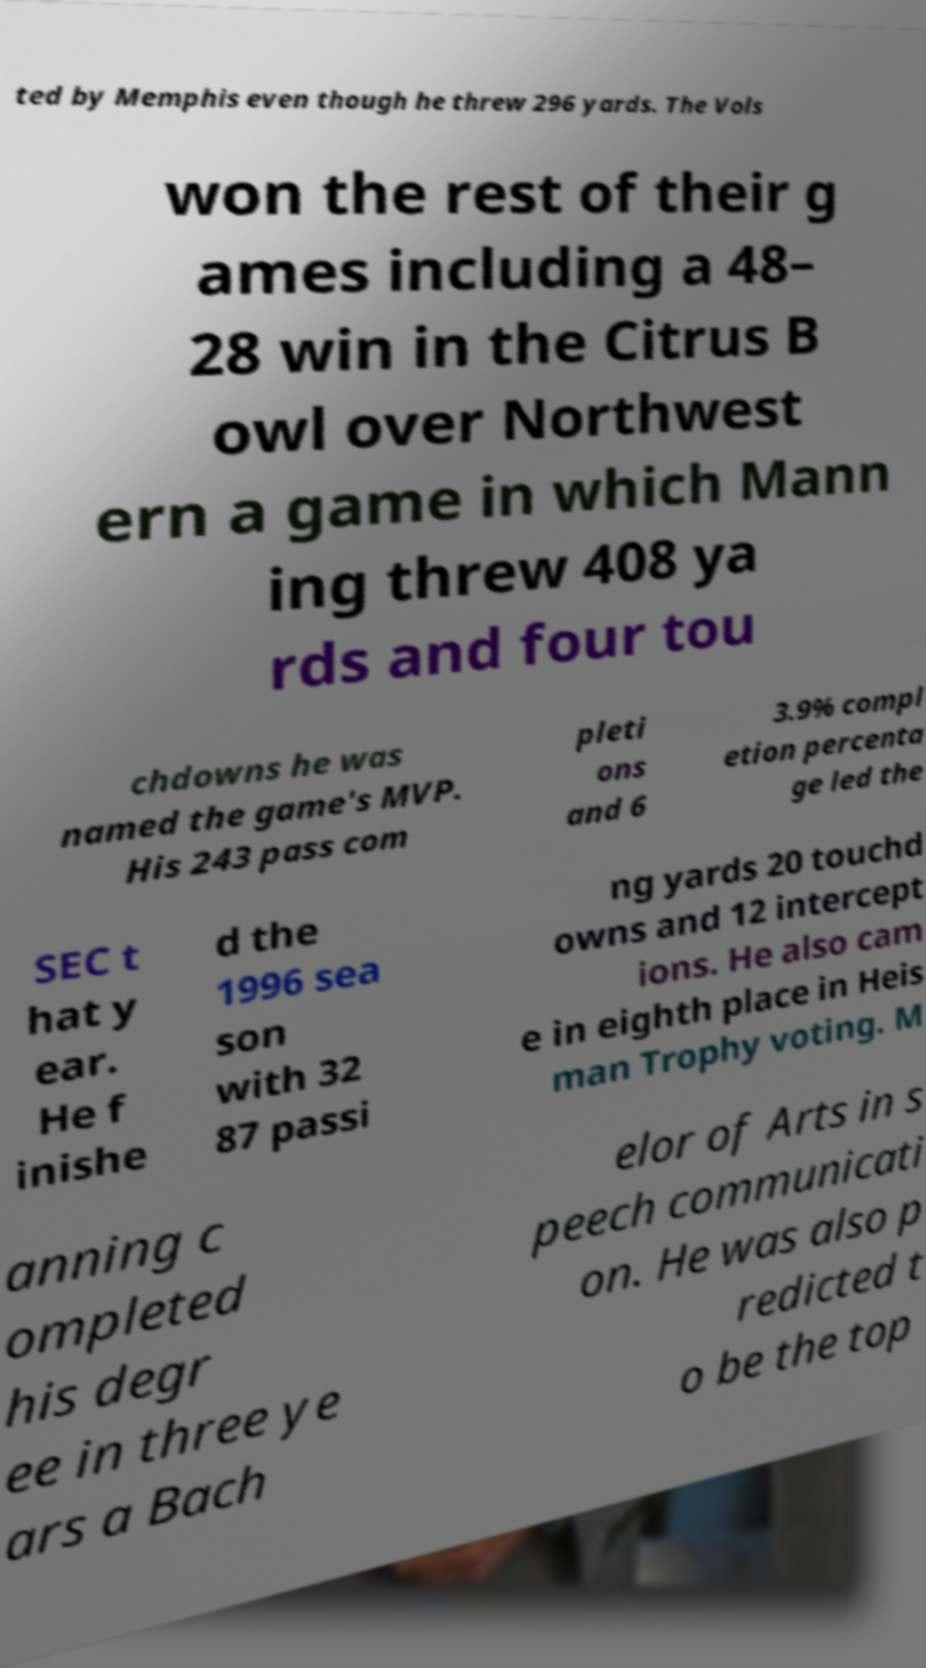For documentation purposes, I need the text within this image transcribed. Could you provide that? ted by Memphis even though he threw 296 yards. The Vols won the rest of their g ames including a 48– 28 win in the Citrus B owl over Northwest ern a game in which Mann ing threw 408 ya rds and four tou chdowns he was named the game's MVP. His 243 pass com pleti ons and 6 3.9% compl etion percenta ge led the SEC t hat y ear. He f inishe d the 1996 sea son with 32 87 passi ng yards 20 touchd owns and 12 intercept ions. He also cam e in eighth place in Heis man Trophy voting. M anning c ompleted his degr ee in three ye ars a Bach elor of Arts in s peech communicati on. He was also p redicted t o be the top 